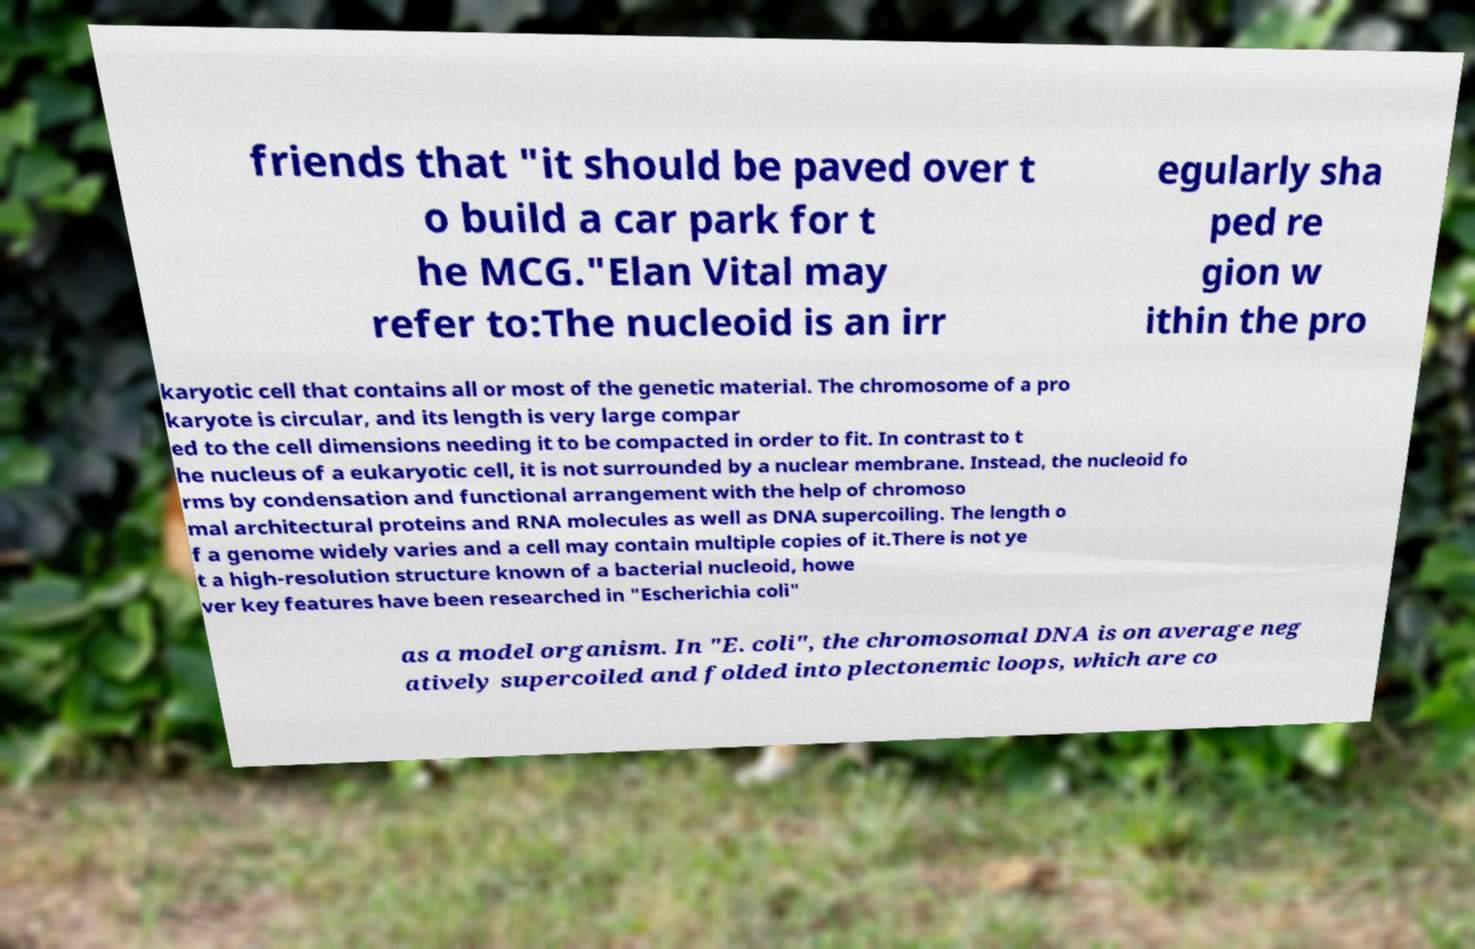Please identify and transcribe the text found in this image. friends that "it should be paved over t o build a car park for t he MCG."Elan Vital may refer to:The nucleoid is an irr egularly sha ped re gion w ithin the pro karyotic cell that contains all or most of the genetic material. The chromosome of a pro karyote is circular, and its length is very large compar ed to the cell dimensions needing it to be compacted in order to fit. In contrast to t he nucleus of a eukaryotic cell, it is not surrounded by a nuclear membrane. Instead, the nucleoid fo rms by condensation and functional arrangement with the help of chromoso mal architectural proteins and RNA molecules as well as DNA supercoiling. The length o f a genome widely varies and a cell may contain multiple copies of it.There is not ye t a high-resolution structure known of a bacterial nucleoid, howe ver key features have been researched in "Escherichia coli" as a model organism. In "E. coli", the chromosomal DNA is on average neg atively supercoiled and folded into plectonemic loops, which are co 